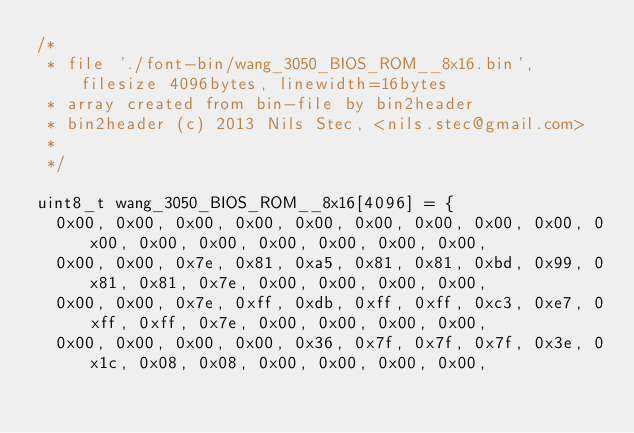Convert code to text. <code><loc_0><loc_0><loc_500><loc_500><_C_>/*
 * file './font-bin/wang_3050_BIOS_ROM__8x16.bin', filesize 4096bytes, linewidth=16bytes
 * array created from bin-file by bin2header
 * bin2header (c) 2013 Nils Stec, <nils.stec@gmail.com>
 *
 */

uint8_t wang_3050_BIOS_ROM__8x16[4096] = {
	0x00, 0x00, 0x00, 0x00, 0x00, 0x00, 0x00, 0x00, 0x00, 0x00, 0x00, 0x00, 0x00, 0x00, 0x00, 0x00, 
	0x00, 0x00, 0x7e, 0x81, 0xa5, 0x81, 0x81, 0xbd, 0x99, 0x81, 0x81, 0x7e, 0x00, 0x00, 0x00, 0x00, 
	0x00, 0x00, 0x7e, 0xff, 0xdb, 0xff, 0xff, 0xc3, 0xe7, 0xff, 0xff, 0x7e, 0x00, 0x00, 0x00, 0x00, 
	0x00, 0x00, 0x00, 0x00, 0x36, 0x7f, 0x7f, 0x7f, 0x3e, 0x1c, 0x08, 0x08, 0x00, 0x00, 0x00, 0x00, </code> 